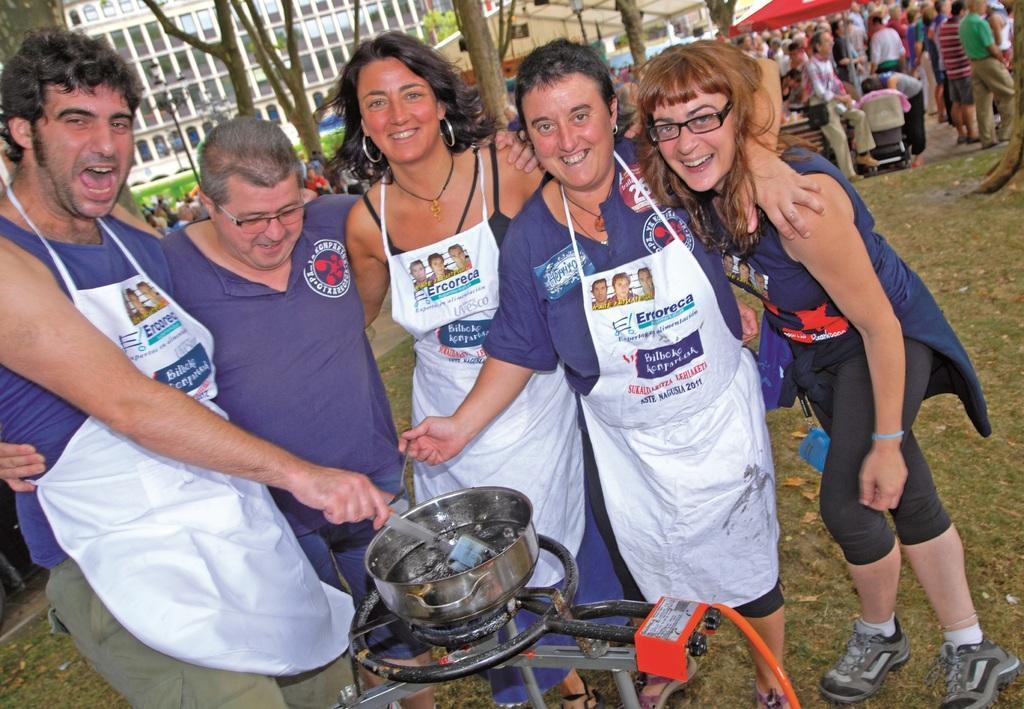In one or two sentences, can you explain what this image depicts? In this picture there are people in the center of the image, there is a stove at the bottom side of the image, there is an utensil on the stove, it seems to be they are cooking and there are other people, stalls, trees, and buildings in the background area of the image. 